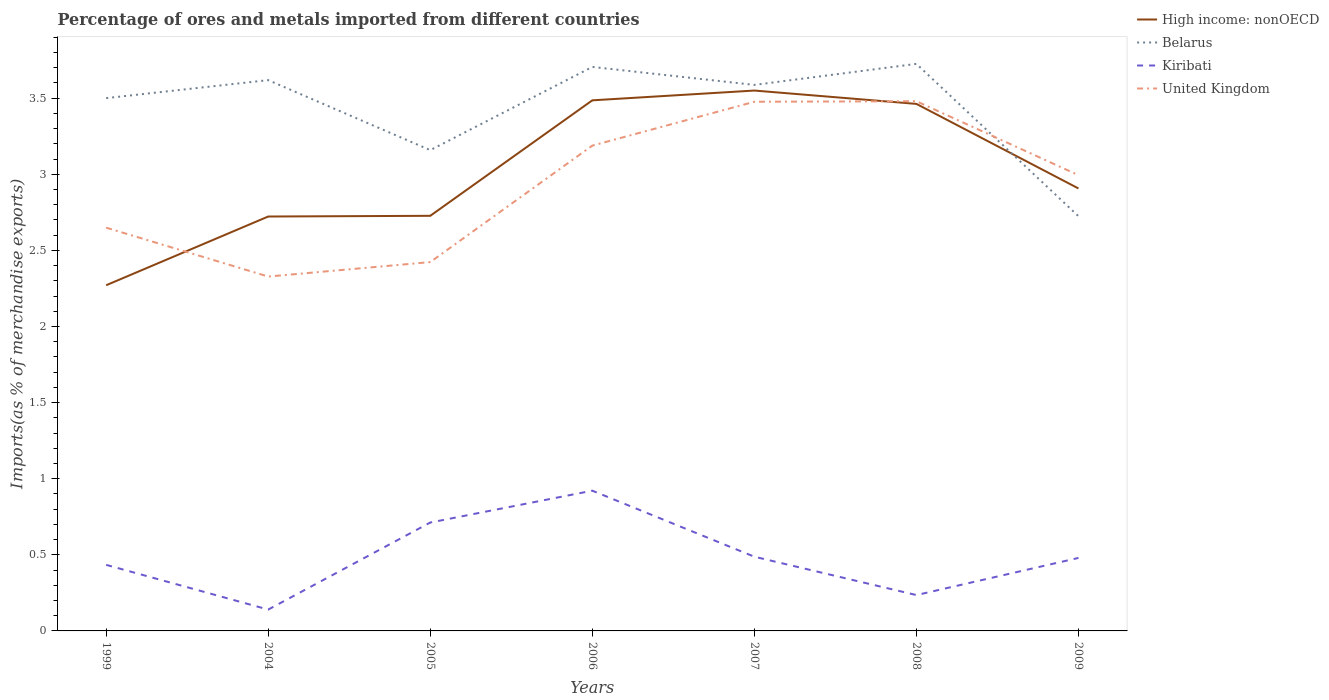Does the line corresponding to High income: nonOECD intersect with the line corresponding to Kiribati?
Your answer should be compact. No. Across all years, what is the maximum percentage of imports to different countries in High income: nonOECD?
Give a very brief answer. 2.27. What is the total percentage of imports to different countries in Kiribati in the graph?
Your response must be concise. -0.05. What is the difference between the highest and the second highest percentage of imports to different countries in Kiribati?
Your response must be concise. 0.78. Is the percentage of imports to different countries in Belarus strictly greater than the percentage of imports to different countries in High income: nonOECD over the years?
Offer a terse response. No. How many lines are there?
Keep it short and to the point. 4. Are the values on the major ticks of Y-axis written in scientific E-notation?
Provide a succinct answer. No. Does the graph contain any zero values?
Ensure brevity in your answer.  No. Does the graph contain grids?
Provide a succinct answer. No. How many legend labels are there?
Your answer should be very brief. 4. What is the title of the graph?
Provide a short and direct response. Percentage of ores and metals imported from different countries. What is the label or title of the Y-axis?
Your answer should be compact. Imports(as % of merchandise exports). What is the Imports(as % of merchandise exports) in High income: nonOECD in 1999?
Your answer should be compact. 2.27. What is the Imports(as % of merchandise exports) in Belarus in 1999?
Provide a succinct answer. 3.5. What is the Imports(as % of merchandise exports) of Kiribati in 1999?
Give a very brief answer. 0.43. What is the Imports(as % of merchandise exports) of United Kingdom in 1999?
Ensure brevity in your answer.  2.65. What is the Imports(as % of merchandise exports) of High income: nonOECD in 2004?
Make the answer very short. 2.72. What is the Imports(as % of merchandise exports) in Belarus in 2004?
Make the answer very short. 3.62. What is the Imports(as % of merchandise exports) of Kiribati in 2004?
Provide a short and direct response. 0.14. What is the Imports(as % of merchandise exports) of United Kingdom in 2004?
Offer a terse response. 2.33. What is the Imports(as % of merchandise exports) in High income: nonOECD in 2005?
Give a very brief answer. 2.73. What is the Imports(as % of merchandise exports) in Belarus in 2005?
Your answer should be very brief. 3.16. What is the Imports(as % of merchandise exports) of Kiribati in 2005?
Your answer should be compact. 0.71. What is the Imports(as % of merchandise exports) in United Kingdom in 2005?
Provide a short and direct response. 2.42. What is the Imports(as % of merchandise exports) in High income: nonOECD in 2006?
Provide a succinct answer. 3.49. What is the Imports(as % of merchandise exports) of Belarus in 2006?
Ensure brevity in your answer.  3.71. What is the Imports(as % of merchandise exports) of Kiribati in 2006?
Make the answer very short. 0.92. What is the Imports(as % of merchandise exports) of United Kingdom in 2006?
Your answer should be compact. 3.19. What is the Imports(as % of merchandise exports) of High income: nonOECD in 2007?
Ensure brevity in your answer.  3.55. What is the Imports(as % of merchandise exports) of Belarus in 2007?
Provide a short and direct response. 3.59. What is the Imports(as % of merchandise exports) of Kiribati in 2007?
Offer a very short reply. 0.49. What is the Imports(as % of merchandise exports) of United Kingdom in 2007?
Your answer should be very brief. 3.48. What is the Imports(as % of merchandise exports) of High income: nonOECD in 2008?
Ensure brevity in your answer.  3.46. What is the Imports(as % of merchandise exports) in Belarus in 2008?
Make the answer very short. 3.73. What is the Imports(as % of merchandise exports) of Kiribati in 2008?
Your answer should be very brief. 0.24. What is the Imports(as % of merchandise exports) of United Kingdom in 2008?
Your answer should be very brief. 3.48. What is the Imports(as % of merchandise exports) of High income: nonOECD in 2009?
Offer a very short reply. 2.91. What is the Imports(as % of merchandise exports) in Belarus in 2009?
Ensure brevity in your answer.  2.72. What is the Imports(as % of merchandise exports) in Kiribati in 2009?
Your response must be concise. 0.48. What is the Imports(as % of merchandise exports) of United Kingdom in 2009?
Offer a terse response. 2.99. Across all years, what is the maximum Imports(as % of merchandise exports) in High income: nonOECD?
Provide a short and direct response. 3.55. Across all years, what is the maximum Imports(as % of merchandise exports) in Belarus?
Keep it short and to the point. 3.73. Across all years, what is the maximum Imports(as % of merchandise exports) in Kiribati?
Offer a terse response. 0.92. Across all years, what is the maximum Imports(as % of merchandise exports) in United Kingdom?
Provide a short and direct response. 3.48. Across all years, what is the minimum Imports(as % of merchandise exports) in High income: nonOECD?
Provide a short and direct response. 2.27. Across all years, what is the minimum Imports(as % of merchandise exports) of Belarus?
Provide a succinct answer. 2.72. Across all years, what is the minimum Imports(as % of merchandise exports) in Kiribati?
Provide a succinct answer. 0.14. Across all years, what is the minimum Imports(as % of merchandise exports) of United Kingdom?
Your answer should be compact. 2.33. What is the total Imports(as % of merchandise exports) in High income: nonOECD in the graph?
Your answer should be very brief. 21.12. What is the total Imports(as % of merchandise exports) of Belarus in the graph?
Offer a terse response. 24.02. What is the total Imports(as % of merchandise exports) of Kiribati in the graph?
Offer a very short reply. 3.41. What is the total Imports(as % of merchandise exports) in United Kingdom in the graph?
Provide a short and direct response. 20.54. What is the difference between the Imports(as % of merchandise exports) in High income: nonOECD in 1999 and that in 2004?
Provide a short and direct response. -0.45. What is the difference between the Imports(as % of merchandise exports) in Belarus in 1999 and that in 2004?
Provide a short and direct response. -0.12. What is the difference between the Imports(as % of merchandise exports) in Kiribati in 1999 and that in 2004?
Keep it short and to the point. 0.29. What is the difference between the Imports(as % of merchandise exports) in United Kingdom in 1999 and that in 2004?
Ensure brevity in your answer.  0.32. What is the difference between the Imports(as % of merchandise exports) in High income: nonOECD in 1999 and that in 2005?
Keep it short and to the point. -0.46. What is the difference between the Imports(as % of merchandise exports) in Belarus in 1999 and that in 2005?
Your answer should be compact. 0.34. What is the difference between the Imports(as % of merchandise exports) of Kiribati in 1999 and that in 2005?
Keep it short and to the point. -0.28. What is the difference between the Imports(as % of merchandise exports) of United Kingdom in 1999 and that in 2005?
Your response must be concise. 0.23. What is the difference between the Imports(as % of merchandise exports) in High income: nonOECD in 1999 and that in 2006?
Your answer should be very brief. -1.21. What is the difference between the Imports(as % of merchandise exports) of Belarus in 1999 and that in 2006?
Keep it short and to the point. -0.2. What is the difference between the Imports(as % of merchandise exports) in Kiribati in 1999 and that in 2006?
Your answer should be compact. -0.49. What is the difference between the Imports(as % of merchandise exports) in United Kingdom in 1999 and that in 2006?
Make the answer very short. -0.54. What is the difference between the Imports(as % of merchandise exports) of High income: nonOECD in 1999 and that in 2007?
Your answer should be very brief. -1.28. What is the difference between the Imports(as % of merchandise exports) in Belarus in 1999 and that in 2007?
Offer a very short reply. -0.09. What is the difference between the Imports(as % of merchandise exports) of Kiribati in 1999 and that in 2007?
Your answer should be compact. -0.05. What is the difference between the Imports(as % of merchandise exports) of United Kingdom in 1999 and that in 2007?
Offer a terse response. -0.83. What is the difference between the Imports(as % of merchandise exports) of High income: nonOECD in 1999 and that in 2008?
Provide a succinct answer. -1.19. What is the difference between the Imports(as % of merchandise exports) in Belarus in 1999 and that in 2008?
Provide a short and direct response. -0.23. What is the difference between the Imports(as % of merchandise exports) of Kiribati in 1999 and that in 2008?
Offer a terse response. 0.2. What is the difference between the Imports(as % of merchandise exports) of United Kingdom in 1999 and that in 2008?
Offer a very short reply. -0.83. What is the difference between the Imports(as % of merchandise exports) of High income: nonOECD in 1999 and that in 2009?
Keep it short and to the point. -0.64. What is the difference between the Imports(as % of merchandise exports) of Belarus in 1999 and that in 2009?
Provide a succinct answer. 0.78. What is the difference between the Imports(as % of merchandise exports) of Kiribati in 1999 and that in 2009?
Offer a very short reply. -0.05. What is the difference between the Imports(as % of merchandise exports) of United Kingdom in 1999 and that in 2009?
Offer a terse response. -0.34. What is the difference between the Imports(as % of merchandise exports) of High income: nonOECD in 2004 and that in 2005?
Give a very brief answer. -0. What is the difference between the Imports(as % of merchandise exports) in Belarus in 2004 and that in 2005?
Give a very brief answer. 0.46. What is the difference between the Imports(as % of merchandise exports) in Kiribati in 2004 and that in 2005?
Offer a very short reply. -0.57. What is the difference between the Imports(as % of merchandise exports) of United Kingdom in 2004 and that in 2005?
Your answer should be compact. -0.1. What is the difference between the Imports(as % of merchandise exports) in High income: nonOECD in 2004 and that in 2006?
Your answer should be compact. -0.76. What is the difference between the Imports(as % of merchandise exports) in Belarus in 2004 and that in 2006?
Provide a succinct answer. -0.09. What is the difference between the Imports(as % of merchandise exports) in Kiribati in 2004 and that in 2006?
Provide a succinct answer. -0.78. What is the difference between the Imports(as % of merchandise exports) of United Kingdom in 2004 and that in 2006?
Offer a terse response. -0.86. What is the difference between the Imports(as % of merchandise exports) in High income: nonOECD in 2004 and that in 2007?
Make the answer very short. -0.83. What is the difference between the Imports(as % of merchandise exports) in Belarus in 2004 and that in 2007?
Provide a succinct answer. 0.03. What is the difference between the Imports(as % of merchandise exports) in Kiribati in 2004 and that in 2007?
Offer a terse response. -0.35. What is the difference between the Imports(as % of merchandise exports) in United Kingdom in 2004 and that in 2007?
Keep it short and to the point. -1.15. What is the difference between the Imports(as % of merchandise exports) of High income: nonOECD in 2004 and that in 2008?
Give a very brief answer. -0.74. What is the difference between the Imports(as % of merchandise exports) in Belarus in 2004 and that in 2008?
Make the answer very short. -0.11. What is the difference between the Imports(as % of merchandise exports) in Kiribati in 2004 and that in 2008?
Your response must be concise. -0.1. What is the difference between the Imports(as % of merchandise exports) of United Kingdom in 2004 and that in 2008?
Provide a short and direct response. -1.15. What is the difference between the Imports(as % of merchandise exports) of High income: nonOECD in 2004 and that in 2009?
Your response must be concise. -0.18. What is the difference between the Imports(as % of merchandise exports) of Belarus in 2004 and that in 2009?
Provide a succinct answer. 0.89. What is the difference between the Imports(as % of merchandise exports) of Kiribati in 2004 and that in 2009?
Your response must be concise. -0.34. What is the difference between the Imports(as % of merchandise exports) in United Kingdom in 2004 and that in 2009?
Provide a succinct answer. -0.67. What is the difference between the Imports(as % of merchandise exports) of High income: nonOECD in 2005 and that in 2006?
Provide a succinct answer. -0.76. What is the difference between the Imports(as % of merchandise exports) in Belarus in 2005 and that in 2006?
Give a very brief answer. -0.55. What is the difference between the Imports(as % of merchandise exports) in Kiribati in 2005 and that in 2006?
Provide a succinct answer. -0.21. What is the difference between the Imports(as % of merchandise exports) in United Kingdom in 2005 and that in 2006?
Ensure brevity in your answer.  -0.77. What is the difference between the Imports(as % of merchandise exports) in High income: nonOECD in 2005 and that in 2007?
Provide a short and direct response. -0.82. What is the difference between the Imports(as % of merchandise exports) of Belarus in 2005 and that in 2007?
Make the answer very short. -0.43. What is the difference between the Imports(as % of merchandise exports) of Kiribati in 2005 and that in 2007?
Offer a very short reply. 0.22. What is the difference between the Imports(as % of merchandise exports) in United Kingdom in 2005 and that in 2007?
Keep it short and to the point. -1.05. What is the difference between the Imports(as % of merchandise exports) of High income: nonOECD in 2005 and that in 2008?
Ensure brevity in your answer.  -0.74. What is the difference between the Imports(as % of merchandise exports) in Belarus in 2005 and that in 2008?
Ensure brevity in your answer.  -0.57. What is the difference between the Imports(as % of merchandise exports) of Kiribati in 2005 and that in 2008?
Keep it short and to the point. 0.48. What is the difference between the Imports(as % of merchandise exports) of United Kingdom in 2005 and that in 2008?
Your answer should be very brief. -1.06. What is the difference between the Imports(as % of merchandise exports) of High income: nonOECD in 2005 and that in 2009?
Your answer should be compact. -0.18. What is the difference between the Imports(as % of merchandise exports) in Belarus in 2005 and that in 2009?
Provide a succinct answer. 0.43. What is the difference between the Imports(as % of merchandise exports) in Kiribati in 2005 and that in 2009?
Provide a succinct answer. 0.23. What is the difference between the Imports(as % of merchandise exports) in United Kingdom in 2005 and that in 2009?
Your response must be concise. -0.57. What is the difference between the Imports(as % of merchandise exports) in High income: nonOECD in 2006 and that in 2007?
Your response must be concise. -0.06. What is the difference between the Imports(as % of merchandise exports) in Belarus in 2006 and that in 2007?
Make the answer very short. 0.12. What is the difference between the Imports(as % of merchandise exports) of Kiribati in 2006 and that in 2007?
Keep it short and to the point. 0.43. What is the difference between the Imports(as % of merchandise exports) in United Kingdom in 2006 and that in 2007?
Provide a short and direct response. -0.29. What is the difference between the Imports(as % of merchandise exports) in High income: nonOECD in 2006 and that in 2008?
Provide a short and direct response. 0.02. What is the difference between the Imports(as % of merchandise exports) of Belarus in 2006 and that in 2008?
Give a very brief answer. -0.02. What is the difference between the Imports(as % of merchandise exports) in Kiribati in 2006 and that in 2008?
Provide a succinct answer. 0.69. What is the difference between the Imports(as % of merchandise exports) in United Kingdom in 2006 and that in 2008?
Offer a very short reply. -0.29. What is the difference between the Imports(as % of merchandise exports) of High income: nonOECD in 2006 and that in 2009?
Keep it short and to the point. 0.58. What is the difference between the Imports(as % of merchandise exports) of Belarus in 2006 and that in 2009?
Your answer should be very brief. 0.98. What is the difference between the Imports(as % of merchandise exports) of Kiribati in 2006 and that in 2009?
Your answer should be compact. 0.44. What is the difference between the Imports(as % of merchandise exports) of United Kingdom in 2006 and that in 2009?
Offer a terse response. 0.19. What is the difference between the Imports(as % of merchandise exports) of High income: nonOECD in 2007 and that in 2008?
Offer a very short reply. 0.09. What is the difference between the Imports(as % of merchandise exports) of Belarus in 2007 and that in 2008?
Your response must be concise. -0.14. What is the difference between the Imports(as % of merchandise exports) in Kiribati in 2007 and that in 2008?
Keep it short and to the point. 0.25. What is the difference between the Imports(as % of merchandise exports) in United Kingdom in 2007 and that in 2008?
Your answer should be compact. -0. What is the difference between the Imports(as % of merchandise exports) in High income: nonOECD in 2007 and that in 2009?
Offer a terse response. 0.64. What is the difference between the Imports(as % of merchandise exports) in Belarus in 2007 and that in 2009?
Your answer should be very brief. 0.86. What is the difference between the Imports(as % of merchandise exports) in Kiribati in 2007 and that in 2009?
Provide a short and direct response. 0.01. What is the difference between the Imports(as % of merchandise exports) in United Kingdom in 2007 and that in 2009?
Your response must be concise. 0.48. What is the difference between the Imports(as % of merchandise exports) of High income: nonOECD in 2008 and that in 2009?
Make the answer very short. 0.56. What is the difference between the Imports(as % of merchandise exports) of Kiribati in 2008 and that in 2009?
Your answer should be very brief. -0.24. What is the difference between the Imports(as % of merchandise exports) in United Kingdom in 2008 and that in 2009?
Give a very brief answer. 0.49. What is the difference between the Imports(as % of merchandise exports) of High income: nonOECD in 1999 and the Imports(as % of merchandise exports) of Belarus in 2004?
Offer a terse response. -1.35. What is the difference between the Imports(as % of merchandise exports) in High income: nonOECD in 1999 and the Imports(as % of merchandise exports) in Kiribati in 2004?
Provide a short and direct response. 2.13. What is the difference between the Imports(as % of merchandise exports) in High income: nonOECD in 1999 and the Imports(as % of merchandise exports) in United Kingdom in 2004?
Your answer should be very brief. -0.06. What is the difference between the Imports(as % of merchandise exports) of Belarus in 1999 and the Imports(as % of merchandise exports) of Kiribati in 2004?
Offer a terse response. 3.36. What is the difference between the Imports(as % of merchandise exports) of Belarus in 1999 and the Imports(as % of merchandise exports) of United Kingdom in 2004?
Give a very brief answer. 1.17. What is the difference between the Imports(as % of merchandise exports) in Kiribati in 1999 and the Imports(as % of merchandise exports) in United Kingdom in 2004?
Offer a terse response. -1.89. What is the difference between the Imports(as % of merchandise exports) of High income: nonOECD in 1999 and the Imports(as % of merchandise exports) of Belarus in 2005?
Give a very brief answer. -0.89. What is the difference between the Imports(as % of merchandise exports) in High income: nonOECD in 1999 and the Imports(as % of merchandise exports) in Kiribati in 2005?
Your answer should be compact. 1.56. What is the difference between the Imports(as % of merchandise exports) in High income: nonOECD in 1999 and the Imports(as % of merchandise exports) in United Kingdom in 2005?
Keep it short and to the point. -0.15. What is the difference between the Imports(as % of merchandise exports) of Belarus in 1999 and the Imports(as % of merchandise exports) of Kiribati in 2005?
Keep it short and to the point. 2.79. What is the difference between the Imports(as % of merchandise exports) in Belarus in 1999 and the Imports(as % of merchandise exports) in United Kingdom in 2005?
Offer a very short reply. 1.08. What is the difference between the Imports(as % of merchandise exports) of Kiribati in 1999 and the Imports(as % of merchandise exports) of United Kingdom in 2005?
Keep it short and to the point. -1.99. What is the difference between the Imports(as % of merchandise exports) in High income: nonOECD in 1999 and the Imports(as % of merchandise exports) in Belarus in 2006?
Your answer should be compact. -1.43. What is the difference between the Imports(as % of merchandise exports) in High income: nonOECD in 1999 and the Imports(as % of merchandise exports) in Kiribati in 2006?
Your answer should be compact. 1.35. What is the difference between the Imports(as % of merchandise exports) in High income: nonOECD in 1999 and the Imports(as % of merchandise exports) in United Kingdom in 2006?
Provide a short and direct response. -0.92. What is the difference between the Imports(as % of merchandise exports) of Belarus in 1999 and the Imports(as % of merchandise exports) of Kiribati in 2006?
Your answer should be very brief. 2.58. What is the difference between the Imports(as % of merchandise exports) of Belarus in 1999 and the Imports(as % of merchandise exports) of United Kingdom in 2006?
Provide a short and direct response. 0.31. What is the difference between the Imports(as % of merchandise exports) of Kiribati in 1999 and the Imports(as % of merchandise exports) of United Kingdom in 2006?
Provide a succinct answer. -2.75. What is the difference between the Imports(as % of merchandise exports) in High income: nonOECD in 1999 and the Imports(as % of merchandise exports) in Belarus in 2007?
Ensure brevity in your answer.  -1.32. What is the difference between the Imports(as % of merchandise exports) in High income: nonOECD in 1999 and the Imports(as % of merchandise exports) in Kiribati in 2007?
Provide a succinct answer. 1.78. What is the difference between the Imports(as % of merchandise exports) of High income: nonOECD in 1999 and the Imports(as % of merchandise exports) of United Kingdom in 2007?
Give a very brief answer. -1.21. What is the difference between the Imports(as % of merchandise exports) of Belarus in 1999 and the Imports(as % of merchandise exports) of Kiribati in 2007?
Your answer should be compact. 3.01. What is the difference between the Imports(as % of merchandise exports) of Belarus in 1999 and the Imports(as % of merchandise exports) of United Kingdom in 2007?
Your answer should be compact. 0.02. What is the difference between the Imports(as % of merchandise exports) in Kiribati in 1999 and the Imports(as % of merchandise exports) in United Kingdom in 2007?
Your answer should be compact. -3.04. What is the difference between the Imports(as % of merchandise exports) in High income: nonOECD in 1999 and the Imports(as % of merchandise exports) in Belarus in 2008?
Keep it short and to the point. -1.45. What is the difference between the Imports(as % of merchandise exports) of High income: nonOECD in 1999 and the Imports(as % of merchandise exports) of Kiribati in 2008?
Provide a short and direct response. 2.04. What is the difference between the Imports(as % of merchandise exports) in High income: nonOECD in 1999 and the Imports(as % of merchandise exports) in United Kingdom in 2008?
Ensure brevity in your answer.  -1.21. What is the difference between the Imports(as % of merchandise exports) in Belarus in 1999 and the Imports(as % of merchandise exports) in Kiribati in 2008?
Offer a very short reply. 3.26. What is the difference between the Imports(as % of merchandise exports) in Belarus in 1999 and the Imports(as % of merchandise exports) in United Kingdom in 2008?
Give a very brief answer. 0.02. What is the difference between the Imports(as % of merchandise exports) of Kiribati in 1999 and the Imports(as % of merchandise exports) of United Kingdom in 2008?
Your response must be concise. -3.05. What is the difference between the Imports(as % of merchandise exports) of High income: nonOECD in 1999 and the Imports(as % of merchandise exports) of Belarus in 2009?
Your answer should be very brief. -0.45. What is the difference between the Imports(as % of merchandise exports) of High income: nonOECD in 1999 and the Imports(as % of merchandise exports) of Kiribati in 2009?
Offer a terse response. 1.79. What is the difference between the Imports(as % of merchandise exports) of High income: nonOECD in 1999 and the Imports(as % of merchandise exports) of United Kingdom in 2009?
Offer a terse response. -0.72. What is the difference between the Imports(as % of merchandise exports) in Belarus in 1999 and the Imports(as % of merchandise exports) in Kiribati in 2009?
Offer a very short reply. 3.02. What is the difference between the Imports(as % of merchandise exports) in Belarus in 1999 and the Imports(as % of merchandise exports) in United Kingdom in 2009?
Provide a short and direct response. 0.51. What is the difference between the Imports(as % of merchandise exports) of Kiribati in 1999 and the Imports(as % of merchandise exports) of United Kingdom in 2009?
Your answer should be compact. -2.56. What is the difference between the Imports(as % of merchandise exports) in High income: nonOECD in 2004 and the Imports(as % of merchandise exports) in Belarus in 2005?
Offer a very short reply. -0.44. What is the difference between the Imports(as % of merchandise exports) of High income: nonOECD in 2004 and the Imports(as % of merchandise exports) of Kiribati in 2005?
Your answer should be compact. 2.01. What is the difference between the Imports(as % of merchandise exports) of High income: nonOECD in 2004 and the Imports(as % of merchandise exports) of United Kingdom in 2005?
Your response must be concise. 0.3. What is the difference between the Imports(as % of merchandise exports) of Belarus in 2004 and the Imports(as % of merchandise exports) of Kiribati in 2005?
Make the answer very short. 2.91. What is the difference between the Imports(as % of merchandise exports) in Belarus in 2004 and the Imports(as % of merchandise exports) in United Kingdom in 2005?
Your response must be concise. 1.2. What is the difference between the Imports(as % of merchandise exports) of Kiribati in 2004 and the Imports(as % of merchandise exports) of United Kingdom in 2005?
Keep it short and to the point. -2.28. What is the difference between the Imports(as % of merchandise exports) of High income: nonOECD in 2004 and the Imports(as % of merchandise exports) of Belarus in 2006?
Offer a very short reply. -0.98. What is the difference between the Imports(as % of merchandise exports) of High income: nonOECD in 2004 and the Imports(as % of merchandise exports) of Kiribati in 2006?
Keep it short and to the point. 1.8. What is the difference between the Imports(as % of merchandise exports) of High income: nonOECD in 2004 and the Imports(as % of merchandise exports) of United Kingdom in 2006?
Give a very brief answer. -0.47. What is the difference between the Imports(as % of merchandise exports) of Belarus in 2004 and the Imports(as % of merchandise exports) of Kiribati in 2006?
Keep it short and to the point. 2.7. What is the difference between the Imports(as % of merchandise exports) of Belarus in 2004 and the Imports(as % of merchandise exports) of United Kingdom in 2006?
Offer a terse response. 0.43. What is the difference between the Imports(as % of merchandise exports) in Kiribati in 2004 and the Imports(as % of merchandise exports) in United Kingdom in 2006?
Your response must be concise. -3.05. What is the difference between the Imports(as % of merchandise exports) of High income: nonOECD in 2004 and the Imports(as % of merchandise exports) of Belarus in 2007?
Keep it short and to the point. -0.86. What is the difference between the Imports(as % of merchandise exports) of High income: nonOECD in 2004 and the Imports(as % of merchandise exports) of Kiribati in 2007?
Your answer should be compact. 2.23. What is the difference between the Imports(as % of merchandise exports) of High income: nonOECD in 2004 and the Imports(as % of merchandise exports) of United Kingdom in 2007?
Provide a succinct answer. -0.75. What is the difference between the Imports(as % of merchandise exports) of Belarus in 2004 and the Imports(as % of merchandise exports) of Kiribati in 2007?
Provide a succinct answer. 3.13. What is the difference between the Imports(as % of merchandise exports) of Belarus in 2004 and the Imports(as % of merchandise exports) of United Kingdom in 2007?
Make the answer very short. 0.14. What is the difference between the Imports(as % of merchandise exports) of Kiribati in 2004 and the Imports(as % of merchandise exports) of United Kingdom in 2007?
Your response must be concise. -3.34. What is the difference between the Imports(as % of merchandise exports) of High income: nonOECD in 2004 and the Imports(as % of merchandise exports) of Belarus in 2008?
Make the answer very short. -1. What is the difference between the Imports(as % of merchandise exports) in High income: nonOECD in 2004 and the Imports(as % of merchandise exports) in Kiribati in 2008?
Ensure brevity in your answer.  2.49. What is the difference between the Imports(as % of merchandise exports) in High income: nonOECD in 2004 and the Imports(as % of merchandise exports) in United Kingdom in 2008?
Keep it short and to the point. -0.76. What is the difference between the Imports(as % of merchandise exports) in Belarus in 2004 and the Imports(as % of merchandise exports) in Kiribati in 2008?
Ensure brevity in your answer.  3.38. What is the difference between the Imports(as % of merchandise exports) of Belarus in 2004 and the Imports(as % of merchandise exports) of United Kingdom in 2008?
Your answer should be compact. 0.14. What is the difference between the Imports(as % of merchandise exports) in Kiribati in 2004 and the Imports(as % of merchandise exports) in United Kingdom in 2008?
Offer a very short reply. -3.34. What is the difference between the Imports(as % of merchandise exports) of High income: nonOECD in 2004 and the Imports(as % of merchandise exports) of Belarus in 2009?
Provide a succinct answer. -0. What is the difference between the Imports(as % of merchandise exports) of High income: nonOECD in 2004 and the Imports(as % of merchandise exports) of Kiribati in 2009?
Offer a very short reply. 2.24. What is the difference between the Imports(as % of merchandise exports) of High income: nonOECD in 2004 and the Imports(as % of merchandise exports) of United Kingdom in 2009?
Make the answer very short. -0.27. What is the difference between the Imports(as % of merchandise exports) in Belarus in 2004 and the Imports(as % of merchandise exports) in Kiribati in 2009?
Offer a terse response. 3.14. What is the difference between the Imports(as % of merchandise exports) in Belarus in 2004 and the Imports(as % of merchandise exports) in United Kingdom in 2009?
Make the answer very short. 0.62. What is the difference between the Imports(as % of merchandise exports) in Kiribati in 2004 and the Imports(as % of merchandise exports) in United Kingdom in 2009?
Offer a terse response. -2.85. What is the difference between the Imports(as % of merchandise exports) of High income: nonOECD in 2005 and the Imports(as % of merchandise exports) of Belarus in 2006?
Your answer should be compact. -0.98. What is the difference between the Imports(as % of merchandise exports) of High income: nonOECD in 2005 and the Imports(as % of merchandise exports) of Kiribati in 2006?
Your response must be concise. 1.81. What is the difference between the Imports(as % of merchandise exports) in High income: nonOECD in 2005 and the Imports(as % of merchandise exports) in United Kingdom in 2006?
Offer a very short reply. -0.46. What is the difference between the Imports(as % of merchandise exports) in Belarus in 2005 and the Imports(as % of merchandise exports) in Kiribati in 2006?
Your answer should be very brief. 2.24. What is the difference between the Imports(as % of merchandise exports) in Belarus in 2005 and the Imports(as % of merchandise exports) in United Kingdom in 2006?
Your answer should be very brief. -0.03. What is the difference between the Imports(as % of merchandise exports) in Kiribati in 2005 and the Imports(as % of merchandise exports) in United Kingdom in 2006?
Provide a succinct answer. -2.48. What is the difference between the Imports(as % of merchandise exports) of High income: nonOECD in 2005 and the Imports(as % of merchandise exports) of Belarus in 2007?
Provide a succinct answer. -0.86. What is the difference between the Imports(as % of merchandise exports) of High income: nonOECD in 2005 and the Imports(as % of merchandise exports) of Kiribati in 2007?
Your answer should be compact. 2.24. What is the difference between the Imports(as % of merchandise exports) in High income: nonOECD in 2005 and the Imports(as % of merchandise exports) in United Kingdom in 2007?
Your answer should be very brief. -0.75. What is the difference between the Imports(as % of merchandise exports) of Belarus in 2005 and the Imports(as % of merchandise exports) of Kiribati in 2007?
Offer a terse response. 2.67. What is the difference between the Imports(as % of merchandise exports) in Belarus in 2005 and the Imports(as % of merchandise exports) in United Kingdom in 2007?
Your response must be concise. -0.32. What is the difference between the Imports(as % of merchandise exports) of Kiribati in 2005 and the Imports(as % of merchandise exports) of United Kingdom in 2007?
Offer a terse response. -2.76. What is the difference between the Imports(as % of merchandise exports) of High income: nonOECD in 2005 and the Imports(as % of merchandise exports) of Belarus in 2008?
Your response must be concise. -1. What is the difference between the Imports(as % of merchandise exports) of High income: nonOECD in 2005 and the Imports(as % of merchandise exports) of Kiribati in 2008?
Your answer should be compact. 2.49. What is the difference between the Imports(as % of merchandise exports) of High income: nonOECD in 2005 and the Imports(as % of merchandise exports) of United Kingdom in 2008?
Make the answer very short. -0.75. What is the difference between the Imports(as % of merchandise exports) in Belarus in 2005 and the Imports(as % of merchandise exports) in Kiribati in 2008?
Your answer should be compact. 2.92. What is the difference between the Imports(as % of merchandise exports) of Belarus in 2005 and the Imports(as % of merchandise exports) of United Kingdom in 2008?
Provide a succinct answer. -0.32. What is the difference between the Imports(as % of merchandise exports) in Kiribati in 2005 and the Imports(as % of merchandise exports) in United Kingdom in 2008?
Give a very brief answer. -2.77. What is the difference between the Imports(as % of merchandise exports) of High income: nonOECD in 2005 and the Imports(as % of merchandise exports) of Belarus in 2009?
Make the answer very short. 0. What is the difference between the Imports(as % of merchandise exports) of High income: nonOECD in 2005 and the Imports(as % of merchandise exports) of Kiribati in 2009?
Keep it short and to the point. 2.25. What is the difference between the Imports(as % of merchandise exports) of High income: nonOECD in 2005 and the Imports(as % of merchandise exports) of United Kingdom in 2009?
Keep it short and to the point. -0.27. What is the difference between the Imports(as % of merchandise exports) of Belarus in 2005 and the Imports(as % of merchandise exports) of Kiribati in 2009?
Your answer should be compact. 2.68. What is the difference between the Imports(as % of merchandise exports) of Belarus in 2005 and the Imports(as % of merchandise exports) of United Kingdom in 2009?
Offer a very short reply. 0.16. What is the difference between the Imports(as % of merchandise exports) of Kiribati in 2005 and the Imports(as % of merchandise exports) of United Kingdom in 2009?
Offer a very short reply. -2.28. What is the difference between the Imports(as % of merchandise exports) of High income: nonOECD in 2006 and the Imports(as % of merchandise exports) of Belarus in 2007?
Offer a very short reply. -0.1. What is the difference between the Imports(as % of merchandise exports) in High income: nonOECD in 2006 and the Imports(as % of merchandise exports) in Kiribati in 2007?
Make the answer very short. 3. What is the difference between the Imports(as % of merchandise exports) in High income: nonOECD in 2006 and the Imports(as % of merchandise exports) in United Kingdom in 2007?
Offer a terse response. 0.01. What is the difference between the Imports(as % of merchandise exports) in Belarus in 2006 and the Imports(as % of merchandise exports) in Kiribati in 2007?
Your answer should be very brief. 3.22. What is the difference between the Imports(as % of merchandise exports) in Belarus in 2006 and the Imports(as % of merchandise exports) in United Kingdom in 2007?
Your response must be concise. 0.23. What is the difference between the Imports(as % of merchandise exports) in Kiribati in 2006 and the Imports(as % of merchandise exports) in United Kingdom in 2007?
Your response must be concise. -2.56. What is the difference between the Imports(as % of merchandise exports) in High income: nonOECD in 2006 and the Imports(as % of merchandise exports) in Belarus in 2008?
Provide a succinct answer. -0.24. What is the difference between the Imports(as % of merchandise exports) in High income: nonOECD in 2006 and the Imports(as % of merchandise exports) in Kiribati in 2008?
Make the answer very short. 3.25. What is the difference between the Imports(as % of merchandise exports) in High income: nonOECD in 2006 and the Imports(as % of merchandise exports) in United Kingdom in 2008?
Provide a succinct answer. 0.01. What is the difference between the Imports(as % of merchandise exports) of Belarus in 2006 and the Imports(as % of merchandise exports) of Kiribati in 2008?
Provide a succinct answer. 3.47. What is the difference between the Imports(as % of merchandise exports) of Belarus in 2006 and the Imports(as % of merchandise exports) of United Kingdom in 2008?
Make the answer very short. 0.23. What is the difference between the Imports(as % of merchandise exports) of Kiribati in 2006 and the Imports(as % of merchandise exports) of United Kingdom in 2008?
Give a very brief answer. -2.56. What is the difference between the Imports(as % of merchandise exports) in High income: nonOECD in 2006 and the Imports(as % of merchandise exports) in Belarus in 2009?
Offer a very short reply. 0.76. What is the difference between the Imports(as % of merchandise exports) of High income: nonOECD in 2006 and the Imports(as % of merchandise exports) of Kiribati in 2009?
Ensure brevity in your answer.  3.01. What is the difference between the Imports(as % of merchandise exports) of High income: nonOECD in 2006 and the Imports(as % of merchandise exports) of United Kingdom in 2009?
Your response must be concise. 0.49. What is the difference between the Imports(as % of merchandise exports) in Belarus in 2006 and the Imports(as % of merchandise exports) in Kiribati in 2009?
Your answer should be very brief. 3.23. What is the difference between the Imports(as % of merchandise exports) in Belarus in 2006 and the Imports(as % of merchandise exports) in United Kingdom in 2009?
Offer a terse response. 0.71. What is the difference between the Imports(as % of merchandise exports) in Kiribati in 2006 and the Imports(as % of merchandise exports) in United Kingdom in 2009?
Provide a short and direct response. -2.07. What is the difference between the Imports(as % of merchandise exports) in High income: nonOECD in 2007 and the Imports(as % of merchandise exports) in Belarus in 2008?
Your response must be concise. -0.18. What is the difference between the Imports(as % of merchandise exports) of High income: nonOECD in 2007 and the Imports(as % of merchandise exports) of Kiribati in 2008?
Offer a very short reply. 3.31. What is the difference between the Imports(as % of merchandise exports) of High income: nonOECD in 2007 and the Imports(as % of merchandise exports) of United Kingdom in 2008?
Keep it short and to the point. 0.07. What is the difference between the Imports(as % of merchandise exports) in Belarus in 2007 and the Imports(as % of merchandise exports) in Kiribati in 2008?
Your answer should be compact. 3.35. What is the difference between the Imports(as % of merchandise exports) of Belarus in 2007 and the Imports(as % of merchandise exports) of United Kingdom in 2008?
Your answer should be compact. 0.11. What is the difference between the Imports(as % of merchandise exports) in Kiribati in 2007 and the Imports(as % of merchandise exports) in United Kingdom in 2008?
Provide a short and direct response. -2.99. What is the difference between the Imports(as % of merchandise exports) in High income: nonOECD in 2007 and the Imports(as % of merchandise exports) in Belarus in 2009?
Provide a short and direct response. 0.83. What is the difference between the Imports(as % of merchandise exports) of High income: nonOECD in 2007 and the Imports(as % of merchandise exports) of Kiribati in 2009?
Provide a short and direct response. 3.07. What is the difference between the Imports(as % of merchandise exports) in High income: nonOECD in 2007 and the Imports(as % of merchandise exports) in United Kingdom in 2009?
Keep it short and to the point. 0.56. What is the difference between the Imports(as % of merchandise exports) in Belarus in 2007 and the Imports(as % of merchandise exports) in Kiribati in 2009?
Your response must be concise. 3.11. What is the difference between the Imports(as % of merchandise exports) of Belarus in 2007 and the Imports(as % of merchandise exports) of United Kingdom in 2009?
Your response must be concise. 0.59. What is the difference between the Imports(as % of merchandise exports) of Kiribati in 2007 and the Imports(as % of merchandise exports) of United Kingdom in 2009?
Offer a terse response. -2.51. What is the difference between the Imports(as % of merchandise exports) in High income: nonOECD in 2008 and the Imports(as % of merchandise exports) in Belarus in 2009?
Keep it short and to the point. 0.74. What is the difference between the Imports(as % of merchandise exports) of High income: nonOECD in 2008 and the Imports(as % of merchandise exports) of Kiribati in 2009?
Make the answer very short. 2.98. What is the difference between the Imports(as % of merchandise exports) in High income: nonOECD in 2008 and the Imports(as % of merchandise exports) in United Kingdom in 2009?
Keep it short and to the point. 0.47. What is the difference between the Imports(as % of merchandise exports) in Belarus in 2008 and the Imports(as % of merchandise exports) in Kiribati in 2009?
Give a very brief answer. 3.25. What is the difference between the Imports(as % of merchandise exports) in Belarus in 2008 and the Imports(as % of merchandise exports) in United Kingdom in 2009?
Provide a succinct answer. 0.73. What is the difference between the Imports(as % of merchandise exports) in Kiribati in 2008 and the Imports(as % of merchandise exports) in United Kingdom in 2009?
Offer a very short reply. -2.76. What is the average Imports(as % of merchandise exports) in High income: nonOECD per year?
Your answer should be compact. 3.02. What is the average Imports(as % of merchandise exports) in Belarus per year?
Your response must be concise. 3.43. What is the average Imports(as % of merchandise exports) in Kiribati per year?
Your answer should be compact. 0.49. What is the average Imports(as % of merchandise exports) in United Kingdom per year?
Your response must be concise. 2.93. In the year 1999, what is the difference between the Imports(as % of merchandise exports) in High income: nonOECD and Imports(as % of merchandise exports) in Belarus?
Offer a very short reply. -1.23. In the year 1999, what is the difference between the Imports(as % of merchandise exports) of High income: nonOECD and Imports(as % of merchandise exports) of Kiribati?
Provide a succinct answer. 1.84. In the year 1999, what is the difference between the Imports(as % of merchandise exports) in High income: nonOECD and Imports(as % of merchandise exports) in United Kingdom?
Offer a very short reply. -0.38. In the year 1999, what is the difference between the Imports(as % of merchandise exports) in Belarus and Imports(as % of merchandise exports) in Kiribati?
Provide a succinct answer. 3.07. In the year 1999, what is the difference between the Imports(as % of merchandise exports) of Belarus and Imports(as % of merchandise exports) of United Kingdom?
Keep it short and to the point. 0.85. In the year 1999, what is the difference between the Imports(as % of merchandise exports) in Kiribati and Imports(as % of merchandise exports) in United Kingdom?
Offer a very short reply. -2.22. In the year 2004, what is the difference between the Imports(as % of merchandise exports) in High income: nonOECD and Imports(as % of merchandise exports) in Belarus?
Ensure brevity in your answer.  -0.9. In the year 2004, what is the difference between the Imports(as % of merchandise exports) in High income: nonOECD and Imports(as % of merchandise exports) in Kiribati?
Your answer should be compact. 2.58. In the year 2004, what is the difference between the Imports(as % of merchandise exports) in High income: nonOECD and Imports(as % of merchandise exports) in United Kingdom?
Provide a short and direct response. 0.39. In the year 2004, what is the difference between the Imports(as % of merchandise exports) in Belarus and Imports(as % of merchandise exports) in Kiribati?
Provide a succinct answer. 3.48. In the year 2004, what is the difference between the Imports(as % of merchandise exports) of Belarus and Imports(as % of merchandise exports) of United Kingdom?
Provide a short and direct response. 1.29. In the year 2004, what is the difference between the Imports(as % of merchandise exports) of Kiribati and Imports(as % of merchandise exports) of United Kingdom?
Offer a very short reply. -2.19. In the year 2005, what is the difference between the Imports(as % of merchandise exports) in High income: nonOECD and Imports(as % of merchandise exports) in Belarus?
Your response must be concise. -0.43. In the year 2005, what is the difference between the Imports(as % of merchandise exports) of High income: nonOECD and Imports(as % of merchandise exports) of Kiribati?
Offer a very short reply. 2.01. In the year 2005, what is the difference between the Imports(as % of merchandise exports) of High income: nonOECD and Imports(as % of merchandise exports) of United Kingdom?
Keep it short and to the point. 0.3. In the year 2005, what is the difference between the Imports(as % of merchandise exports) in Belarus and Imports(as % of merchandise exports) in Kiribati?
Your response must be concise. 2.45. In the year 2005, what is the difference between the Imports(as % of merchandise exports) of Belarus and Imports(as % of merchandise exports) of United Kingdom?
Your answer should be very brief. 0.74. In the year 2005, what is the difference between the Imports(as % of merchandise exports) in Kiribati and Imports(as % of merchandise exports) in United Kingdom?
Give a very brief answer. -1.71. In the year 2006, what is the difference between the Imports(as % of merchandise exports) in High income: nonOECD and Imports(as % of merchandise exports) in Belarus?
Your response must be concise. -0.22. In the year 2006, what is the difference between the Imports(as % of merchandise exports) in High income: nonOECD and Imports(as % of merchandise exports) in Kiribati?
Your answer should be compact. 2.56. In the year 2006, what is the difference between the Imports(as % of merchandise exports) in High income: nonOECD and Imports(as % of merchandise exports) in United Kingdom?
Provide a short and direct response. 0.3. In the year 2006, what is the difference between the Imports(as % of merchandise exports) of Belarus and Imports(as % of merchandise exports) of Kiribati?
Offer a terse response. 2.78. In the year 2006, what is the difference between the Imports(as % of merchandise exports) of Belarus and Imports(as % of merchandise exports) of United Kingdom?
Your answer should be very brief. 0.52. In the year 2006, what is the difference between the Imports(as % of merchandise exports) of Kiribati and Imports(as % of merchandise exports) of United Kingdom?
Your response must be concise. -2.27. In the year 2007, what is the difference between the Imports(as % of merchandise exports) in High income: nonOECD and Imports(as % of merchandise exports) in Belarus?
Give a very brief answer. -0.04. In the year 2007, what is the difference between the Imports(as % of merchandise exports) of High income: nonOECD and Imports(as % of merchandise exports) of Kiribati?
Your response must be concise. 3.06. In the year 2007, what is the difference between the Imports(as % of merchandise exports) in High income: nonOECD and Imports(as % of merchandise exports) in United Kingdom?
Your answer should be compact. 0.07. In the year 2007, what is the difference between the Imports(as % of merchandise exports) in Belarus and Imports(as % of merchandise exports) in Kiribati?
Keep it short and to the point. 3.1. In the year 2007, what is the difference between the Imports(as % of merchandise exports) in Belarus and Imports(as % of merchandise exports) in United Kingdom?
Make the answer very short. 0.11. In the year 2007, what is the difference between the Imports(as % of merchandise exports) of Kiribati and Imports(as % of merchandise exports) of United Kingdom?
Your response must be concise. -2.99. In the year 2008, what is the difference between the Imports(as % of merchandise exports) of High income: nonOECD and Imports(as % of merchandise exports) of Belarus?
Offer a terse response. -0.26. In the year 2008, what is the difference between the Imports(as % of merchandise exports) in High income: nonOECD and Imports(as % of merchandise exports) in Kiribati?
Give a very brief answer. 3.23. In the year 2008, what is the difference between the Imports(as % of merchandise exports) of High income: nonOECD and Imports(as % of merchandise exports) of United Kingdom?
Ensure brevity in your answer.  -0.02. In the year 2008, what is the difference between the Imports(as % of merchandise exports) in Belarus and Imports(as % of merchandise exports) in Kiribati?
Keep it short and to the point. 3.49. In the year 2008, what is the difference between the Imports(as % of merchandise exports) of Belarus and Imports(as % of merchandise exports) of United Kingdom?
Offer a terse response. 0.25. In the year 2008, what is the difference between the Imports(as % of merchandise exports) of Kiribati and Imports(as % of merchandise exports) of United Kingdom?
Provide a succinct answer. -3.24. In the year 2009, what is the difference between the Imports(as % of merchandise exports) in High income: nonOECD and Imports(as % of merchandise exports) in Belarus?
Keep it short and to the point. 0.18. In the year 2009, what is the difference between the Imports(as % of merchandise exports) in High income: nonOECD and Imports(as % of merchandise exports) in Kiribati?
Keep it short and to the point. 2.43. In the year 2009, what is the difference between the Imports(as % of merchandise exports) of High income: nonOECD and Imports(as % of merchandise exports) of United Kingdom?
Your response must be concise. -0.09. In the year 2009, what is the difference between the Imports(as % of merchandise exports) of Belarus and Imports(as % of merchandise exports) of Kiribati?
Your answer should be compact. 2.24. In the year 2009, what is the difference between the Imports(as % of merchandise exports) of Belarus and Imports(as % of merchandise exports) of United Kingdom?
Provide a succinct answer. -0.27. In the year 2009, what is the difference between the Imports(as % of merchandise exports) in Kiribati and Imports(as % of merchandise exports) in United Kingdom?
Offer a very short reply. -2.51. What is the ratio of the Imports(as % of merchandise exports) in High income: nonOECD in 1999 to that in 2004?
Provide a succinct answer. 0.83. What is the ratio of the Imports(as % of merchandise exports) of Belarus in 1999 to that in 2004?
Your answer should be very brief. 0.97. What is the ratio of the Imports(as % of merchandise exports) of Kiribati in 1999 to that in 2004?
Ensure brevity in your answer.  3.09. What is the ratio of the Imports(as % of merchandise exports) of United Kingdom in 1999 to that in 2004?
Ensure brevity in your answer.  1.14. What is the ratio of the Imports(as % of merchandise exports) of High income: nonOECD in 1999 to that in 2005?
Give a very brief answer. 0.83. What is the ratio of the Imports(as % of merchandise exports) of Belarus in 1999 to that in 2005?
Give a very brief answer. 1.11. What is the ratio of the Imports(as % of merchandise exports) in Kiribati in 1999 to that in 2005?
Your answer should be compact. 0.61. What is the ratio of the Imports(as % of merchandise exports) in United Kingdom in 1999 to that in 2005?
Keep it short and to the point. 1.09. What is the ratio of the Imports(as % of merchandise exports) of High income: nonOECD in 1999 to that in 2006?
Your answer should be very brief. 0.65. What is the ratio of the Imports(as % of merchandise exports) of Belarus in 1999 to that in 2006?
Provide a short and direct response. 0.94. What is the ratio of the Imports(as % of merchandise exports) of Kiribati in 1999 to that in 2006?
Make the answer very short. 0.47. What is the ratio of the Imports(as % of merchandise exports) in United Kingdom in 1999 to that in 2006?
Provide a succinct answer. 0.83. What is the ratio of the Imports(as % of merchandise exports) in High income: nonOECD in 1999 to that in 2007?
Ensure brevity in your answer.  0.64. What is the ratio of the Imports(as % of merchandise exports) of Belarus in 1999 to that in 2007?
Provide a short and direct response. 0.98. What is the ratio of the Imports(as % of merchandise exports) in Kiribati in 1999 to that in 2007?
Give a very brief answer. 0.89. What is the ratio of the Imports(as % of merchandise exports) in United Kingdom in 1999 to that in 2007?
Your answer should be compact. 0.76. What is the ratio of the Imports(as % of merchandise exports) in High income: nonOECD in 1999 to that in 2008?
Keep it short and to the point. 0.66. What is the ratio of the Imports(as % of merchandise exports) of Belarus in 1999 to that in 2008?
Your answer should be very brief. 0.94. What is the ratio of the Imports(as % of merchandise exports) of Kiribati in 1999 to that in 2008?
Your answer should be very brief. 1.84. What is the ratio of the Imports(as % of merchandise exports) of United Kingdom in 1999 to that in 2008?
Provide a short and direct response. 0.76. What is the ratio of the Imports(as % of merchandise exports) in High income: nonOECD in 1999 to that in 2009?
Keep it short and to the point. 0.78. What is the ratio of the Imports(as % of merchandise exports) in Belarus in 1999 to that in 2009?
Give a very brief answer. 1.28. What is the ratio of the Imports(as % of merchandise exports) of Kiribati in 1999 to that in 2009?
Ensure brevity in your answer.  0.91. What is the ratio of the Imports(as % of merchandise exports) in United Kingdom in 1999 to that in 2009?
Give a very brief answer. 0.88. What is the ratio of the Imports(as % of merchandise exports) in Belarus in 2004 to that in 2005?
Give a very brief answer. 1.15. What is the ratio of the Imports(as % of merchandise exports) of Kiribati in 2004 to that in 2005?
Ensure brevity in your answer.  0.2. What is the ratio of the Imports(as % of merchandise exports) of United Kingdom in 2004 to that in 2005?
Your answer should be compact. 0.96. What is the ratio of the Imports(as % of merchandise exports) in High income: nonOECD in 2004 to that in 2006?
Your answer should be very brief. 0.78. What is the ratio of the Imports(as % of merchandise exports) in Belarus in 2004 to that in 2006?
Your answer should be compact. 0.98. What is the ratio of the Imports(as % of merchandise exports) of Kiribati in 2004 to that in 2006?
Provide a succinct answer. 0.15. What is the ratio of the Imports(as % of merchandise exports) of United Kingdom in 2004 to that in 2006?
Give a very brief answer. 0.73. What is the ratio of the Imports(as % of merchandise exports) of High income: nonOECD in 2004 to that in 2007?
Give a very brief answer. 0.77. What is the ratio of the Imports(as % of merchandise exports) of Belarus in 2004 to that in 2007?
Offer a terse response. 1.01. What is the ratio of the Imports(as % of merchandise exports) of Kiribati in 2004 to that in 2007?
Provide a short and direct response. 0.29. What is the ratio of the Imports(as % of merchandise exports) of United Kingdom in 2004 to that in 2007?
Provide a succinct answer. 0.67. What is the ratio of the Imports(as % of merchandise exports) of High income: nonOECD in 2004 to that in 2008?
Make the answer very short. 0.79. What is the ratio of the Imports(as % of merchandise exports) of Belarus in 2004 to that in 2008?
Keep it short and to the point. 0.97. What is the ratio of the Imports(as % of merchandise exports) in Kiribati in 2004 to that in 2008?
Your answer should be compact. 0.6. What is the ratio of the Imports(as % of merchandise exports) of United Kingdom in 2004 to that in 2008?
Provide a succinct answer. 0.67. What is the ratio of the Imports(as % of merchandise exports) in High income: nonOECD in 2004 to that in 2009?
Make the answer very short. 0.94. What is the ratio of the Imports(as % of merchandise exports) in Belarus in 2004 to that in 2009?
Your answer should be compact. 1.33. What is the ratio of the Imports(as % of merchandise exports) of Kiribati in 2004 to that in 2009?
Your answer should be very brief. 0.29. What is the ratio of the Imports(as % of merchandise exports) of United Kingdom in 2004 to that in 2009?
Offer a terse response. 0.78. What is the ratio of the Imports(as % of merchandise exports) of High income: nonOECD in 2005 to that in 2006?
Keep it short and to the point. 0.78. What is the ratio of the Imports(as % of merchandise exports) of Belarus in 2005 to that in 2006?
Offer a very short reply. 0.85. What is the ratio of the Imports(as % of merchandise exports) in Kiribati in 2005 to that in 2006?
Provide a succinct answer. 0.77. What is the ratio of the Imports(as % of merchandise exports) in United Kingdom in 2005 to that in 2006?
Provide a short and direct response. 0.76. What is the ratio of the Imports(as % of merchandise exports) of High income: nonOECD in 2005 to that in 2007?
Keep it short and to the point. 0.77. What is the ratio of the Imports(as % of merchandise exports) in Belarus in 2005 to that in 2007?
Provide a succinct answer. 0.88. What is the ratio of the Imports(as % of merchandise exports) in Kiribati in 2005 to that in 2007?
Ensure brevity in your answer.  1.46. What is the ratio of the Imports(as % of merchandise exports) in United Kingdom in 2005 to that in 2007?
Provide a short and direct response. 0.7. What is the ratio of the Imports(as % of merchandise exports) in High income: nonOECD in 2005 to that in 2008?
Your answer should be very brief. 0.79. What is the ratio of the Imports(as % of merchandise exports) in Belarus in 2005 to that in 2008?
Provide a short and direct response. 0.85. What is the ratio of the Imports(as % of merchandise exports) of Kiribati in 2005 to that in 2008?
Your answer should be compact. 3.02. What is the ratio of the Imports(as % of merchandise exports) in United Kingdom in 2005 to that in 2008?
Your response must be concise. 0.7. What is the ratio of the Imports(as % of merchandise exports) in High income: nonOECD in 2005 to that in 2009?
Provide a succinct answer. 0.94. What is the ratio of the Imports(as % of merchandise exports) in Belarus in 2005 to that in 2009?
Keep it short and to the point. 1.16. What is the ratio of the Imports(as % of merchandise exports) in Kiribati in 2005 to that in 2009?
Provide a short and direct response. 1.48. What is the ratio of the Imports(as % of merchandise exports) in United Kingdom in 2005 to that in 2009?
Provide a succinct answer. 0.81. What is the ratio of the Imports(as % of merchandise exports) in High income: nonOECD in 2006 to that in 2007?
Offer a very short reply. 0.98. What is the ratio of the Imports(as % of merchandise exports) in Belarus in 2006 to that in 2007?
Your answer should be very brief. 1.03. What is the ratio of the Imports(as % of merchandise exports) of Kiribati in 2006 to that in 2007?
Your response must be concise. 1.89. What is the ratio of the Imports(as % of merchandise exports) of United Kingdom in 2006 to that in 2007?
Give a very brief answer. 0.92. What is the ratio of the Imports(as % of merchandise exports) of High income: nonOECD in 2006 to that in 2008?
Make the answer very short. 1.01. What is the ratio of the Imports(as % of merchandise exports) in Kiribati in 2006 to that in 2008?
Make the answer very short. 3.91. What is the ratio of the Imports(as % of merchandise exports) in United Kingdom in 2006 to that in 2008?
Offer a very short reply. 0.92. What is the ratio of the Imports(as % of merchandise exports) of High income: nonOECD in 2006 to that in 2009?
Your answer should be very brief. 1.2. What is the ratio of the Imports(as % of merchandise exports) of Belarus in 2006 to that in 2009?
Make the answer very short. 1.36. What is the ratio of the Imports(as % of merchandise exports) of Kiribati in 2006 to that in 2009?
Provide a succinct answer. 1.92. What is the ratio of the Imports(as % of merchandise exports) of United Kingdom in 2006 to that in 2009?
Your answer should be compact. 1.06. What is the ratio of the Imports(as % of merchandise exports) in High income: nonOECD in 2007 to that in 2008?
Your answer should be very brief. 1.03. What is the ratio of the Imports(as % of merchandise exports) in Belarus in 2007 to that in 2008?
Make the answer very short. 0.96. What is the ratio of the Imports(as % of merchandise exports) in Kiribati in 2007 to that in 2008?
Make the answer very short. 2.07. What is the ratio of the Imports(as % of merchandise exports) of United Kingdom in 2007 to that in 2008?
Keep it short and to the point. 1. What is the ratio of the Imports(as % of merchandise exports) in High income: nonOECD in 2007 to that in 2009?
Your response must be concise. 1.22. What is the ratio of the Imports(as % of merchandise exports) of Belarus in 2007 to that in 2009?
Make the answer very short. 1.32. What is the ratio of the Imports(as % of merchandise exports) in Kiribati in 2007 to that in 2009?
Ensure brevity in your answer.  1.02. What is the ratio of the Imports(as % of merchandise exports) in United Kingdom in 2007 to that in 2009?
Provide a short and direct response. 1.16. What is the ratio of the Imports(as % of merchandise exports) of High income: nonOECD in 2008 to that in 2009?
Make the answer very short. 1.19. What is the ratio of the Imports(as % of merchandise exports) of Belarus in 2008 to that in 2009?
Provide a short and direct response. 1.37. What is the ratio of the Imports(as % of merchandise exports) in Kiribati in 2008 to that in 2009?
Ensure brevity in your answer.  0.49. What is the ratio of the Imports(as % of merchandise exports) of United Kingdom in 2008 to that in 2009?
Offer a very short reply. 1.16. What is the difference between the highest and the second highest Imports(as % of merchandise exports) of High income: nonOECD?
Your answer should be compact. 0.06. What is the difference between the highest and the second highest Imports(as % of merchandise exports) of Belarus?
Your answer should be compact. 0.02. What is the difference between the highest and the second highest Imports(as % of merchandise exports) in Kiribati?
Give a very brief answer. 0.21. What is the difference between the highest and the second highest Imports(as % of merchandise exports) of United Kingdom?
Your response must be concise. 0. What is the difference between the highest and the lowest Imports(as % of merchandise exports) of High income: nonOECD?
Provide a short and direct response. 1.28. What is the difference between the highest and the lowest Imports(as % of merchandise exports) in Belarus?
Your answer should be compact. 1. What is the difference between the highest and the lowest Imports(as % of merchandise exports) of Kiribati?
Provide a short and direct response. 0.78. What is the difference between the highest and the lowest Imports(as % of merchandise exports) of United Kingdom?
Offer a terse response. 1.15. 